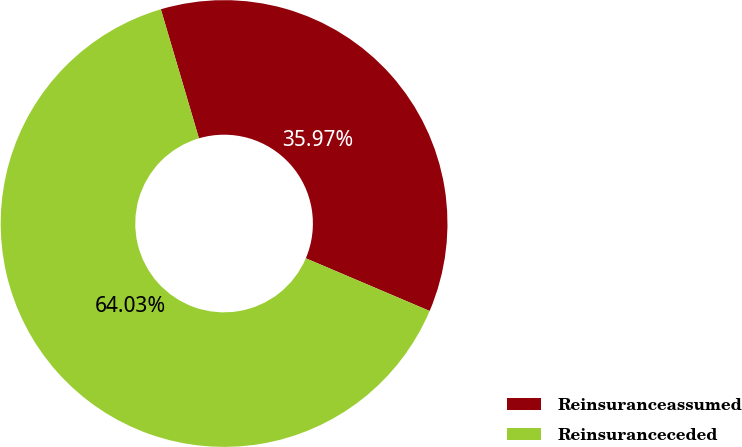Convert chart to OTSL. <chart><loc_0><loc_0><loc_500><loc_500><pie_chart><fcel>Reinsuranceassumed<fcel>Reinsuranceceded<nl><fcel>35.97%<fcel>64.03%<nl></chart> 